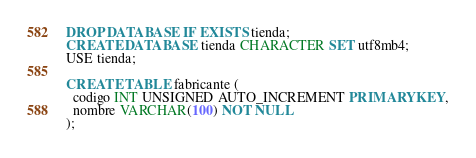<code> <loc_0><loc_0><loc_500><loc_500><_SQL_>DROP DATABASE IF EXISTS tienda;
CREATE DATABASE tienda CHARACTER SET utf8mb4;
USE tienda;

CREATE TABLE fabricante (
  codigo INT UNSIGNED AUTO_INCREMENT PRIMARY KEY,
  nombre VARCHAR(100) NOT NULL
);
</code> 